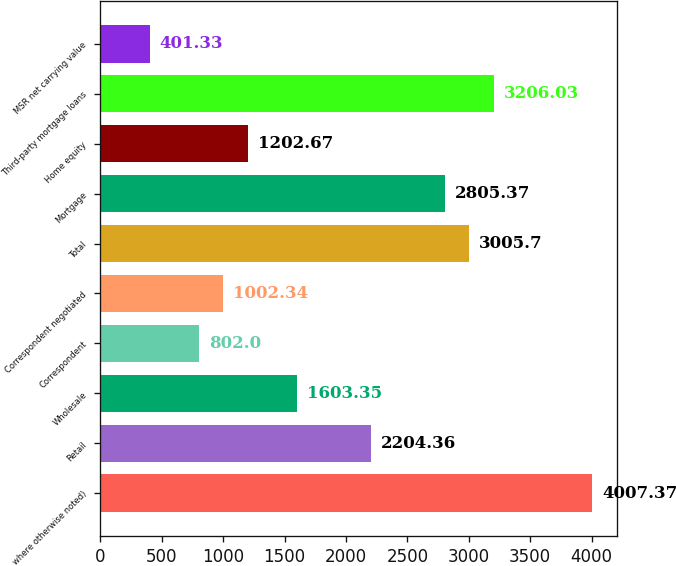Convert chart to OTSL. <chart><loc_0><loc_0><loc_500><loc_500><bar_chart><fcel>where otherwise noted)<fcel>Retail<fcel>Wholesale<fcel>Correspondent<fcel>Correspondent negotiated<fcel>Total<fcel>Mortgage<fcel>Home equity<fcel>Third-party mortgage loans<fcel>MSR net carrying value<nl><fcel>4007.37<fcel>2204.36<fcel>1603.35<fcel>802<fcel>1002.34<fcel>3005.7<fcel>2805.37<fcel>1202.67<fcel>3206.03<fcel>401.33<nl></chart> 